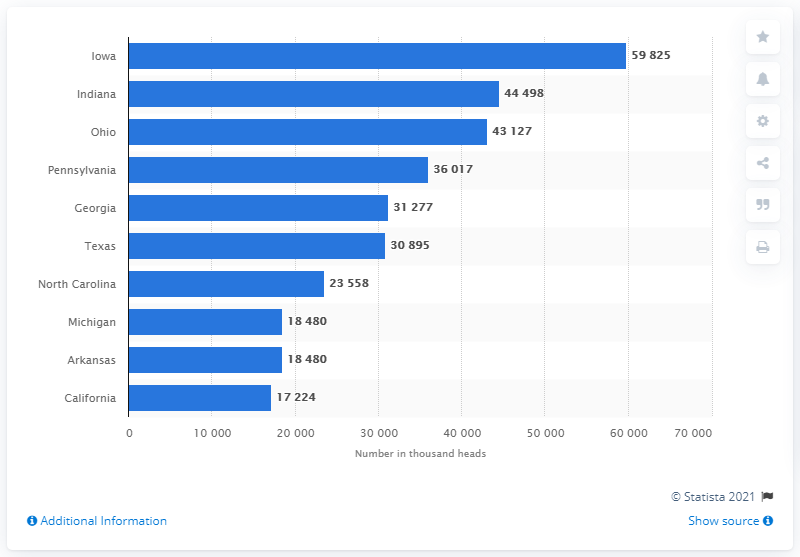Draw attention to some important aspects in this diagram. Iowa had the highest number of chickens in 2020, according to the latest data available. 